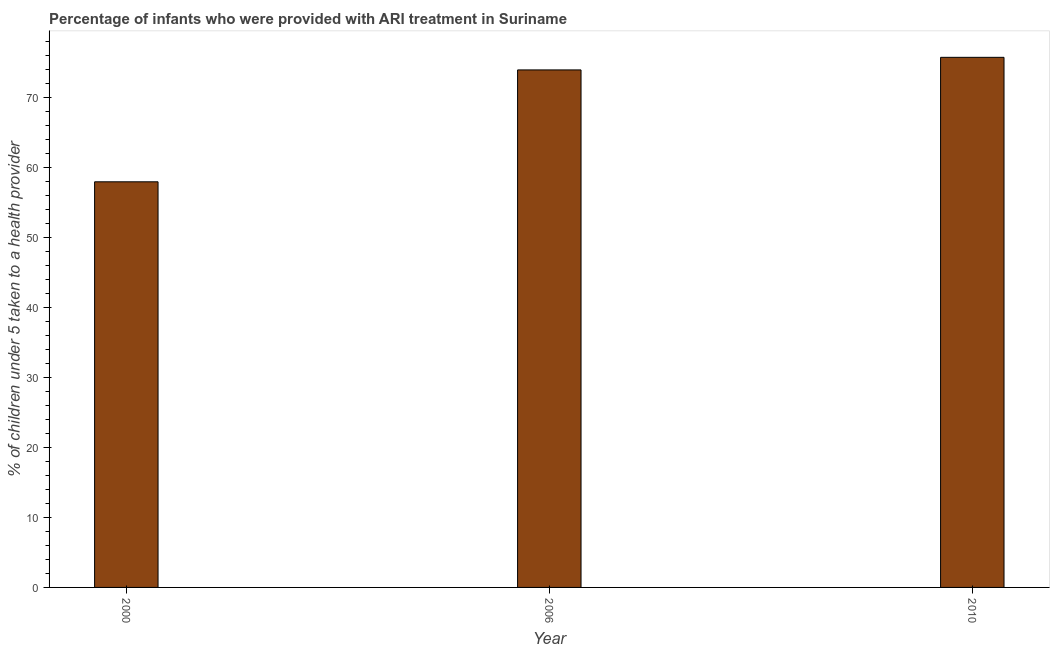Does the graph contain any zero values?
Provide a short and direct response. No. What is the title of the graph?
Keep it short and to the point. Percentage of infants who were provided with ARI treatment in Suriname. What is the label or title of the Y-axis?
Give a very brief answer. % of children under 5 taken to a health provider. Across all years, what is the maximum percentage of children who were provided with ari treatment?
Your answer should be very brief. 75.8. In which year was the percentage of children who were provided with ari treatment maximum?
Ensure brevity in your answer.  2010. In which year was the percentage of children who were provided with ari treatment minimum?
Offer a very short reply. 2000. What is the sum of the percentage of children who were provided with ari treatment?
Give a very brief answer. 207.8. What is the average percentage of children who were provided with ari treatment per year?
Provide a succinct answer. 69.27. Do a majority of the years between 2000 and 2010 (inclusive) have percentage of children who were provided with ari treatment greater than 26 %?
Your response must be concise. Yes. What is the ratio of the percentage of children who were provided with ari treatment in 2000 to that in 2006?
Ensure brevity in your answer.  0.78. Is the difference between the percentage of children who were provided with ari treatment in 2000 and 2006 greater than the difference between any two years?
Provide a succinct answer. No. What is the difference between the highest and the second highest percentage of children who were provided with ari treatment?
Your response must be concise. 1.8. Is the sum of the percentage of children who were provided with ari treatment in 2006 and 2010 greater than the maximum percentage of children who were provided with ari treatment across all years?
Give a very brief answer. Yes. What is the difference between the highest and the lowest percentage of children who were provided with ari treatment?
Your response must be concise. 17.8. What is the difference between two consecutive major ticks on the Y-axis?
Provide a short and direct response. 10. Are the values on the major ticks of Y-axis written in scientific E-notation?
Keep it short and to the point. No. What is the % of children under 5 taken to a health provider of 2000?
Your answer should be compact. 58. What is the % of children under 5 taken to a health provider in 2006?
Your answer should be compact. 74. What is the % of children under 5 taken to a health provider of 2010?
Make the answer very short. 75.8. What is the difference between the % of children under 5 taken to a health provider in 2000 and 2006?
Your response must be concise. -16. What is the difference between the % of children under 5 taken to a health provider in 2000 and 2010?
Your answer should be very brief. -17.8. What is the ratio of the % of children under 5 taken to a health provider in 2000 to that in 2006?
Ensure brevity in your answer.  0.78. What is the ratio of the % of children under 5 taken to a health provider in 2000 to that in 2010?
Your answer should be compact. 0.77. 